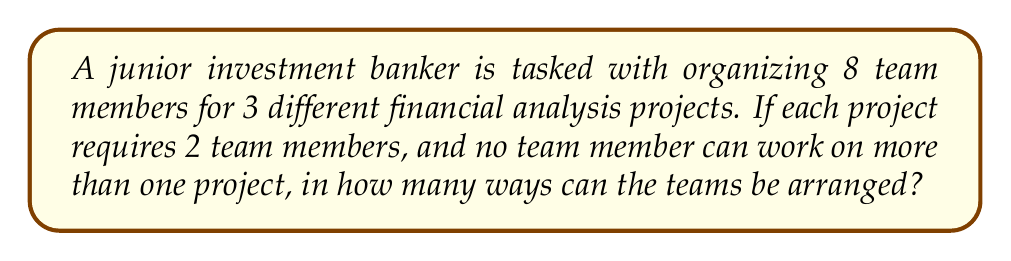Help me with this question. Let's approach this step-by-step:

1) First, we need to choose 2 team members for the first project. This can be done in $\binom{8}{2}$ ways.

2) After selecting the first team, we have 6 team members left, from which we need to choose 2 for the second project. This can be done in $\binom{6}{2}$ ways.

3) For the third project, we have 4 team members left, and we need to choose 2. This can be done in $\binom{4}{2}$ ways.

4) By the multiplication principle, the total number of ways to arrange the teams is:

   $$\binom{8}{2} \cdot \binom{6}{2} \cdot \binom{4}{2}$$

5) Let's calculate each combination:
   
   $\binom{8}{2} = \frac{8!}{2!(8-2)!} = \frac{8 \cdot 7}{2 \cdot 1} = 28$
   
   $\binom{6}{2} = \frac{6!}{2!(6-2)!} = \frac{6 \cdot 5}{2 \cdot 1} = 15$
   
   $\binom{4}{2} = \frac{4!}{2!(4-2)!} = \frac{4 \cdot 3}{2 \cdot 1} = 6$

6) Multiplying these results:

   $$28 \cdot 15 \cdot 6 = 2,520$$

Therefore, there are 2,520 ways to arrange the teams.
Answer: 2,520 